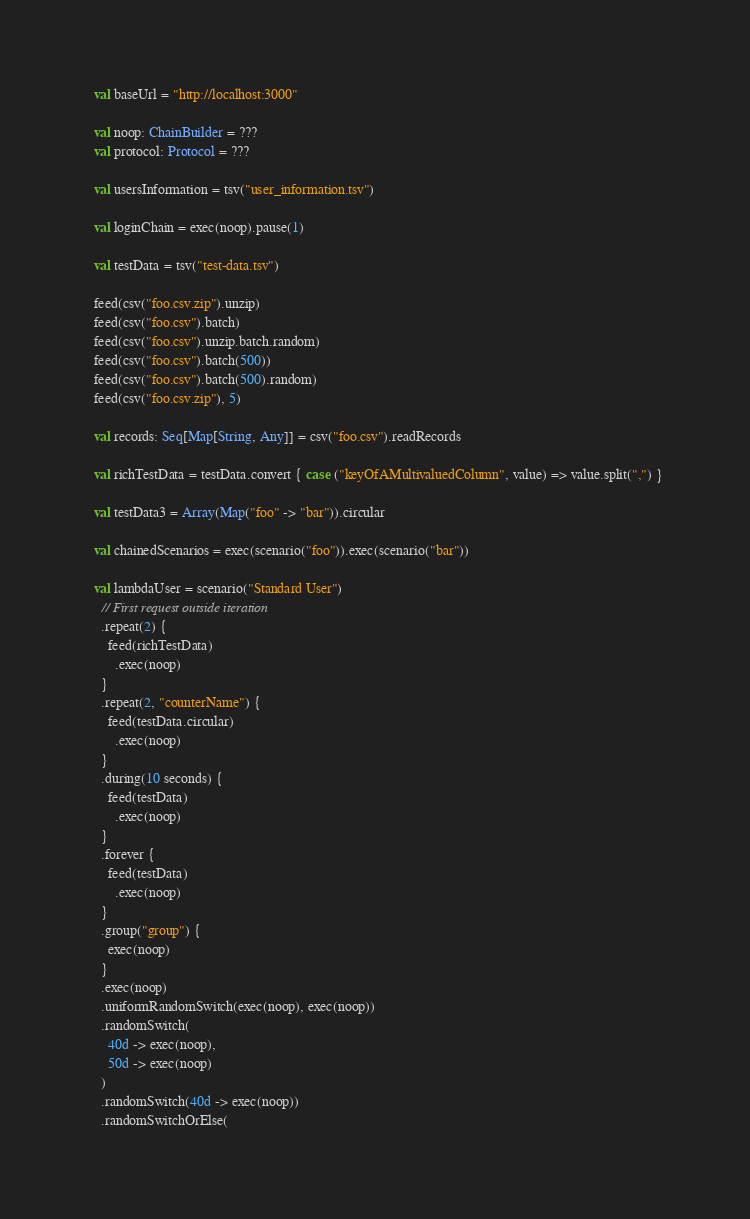<code> <loc_0><loc_0><loc_500><loc_500><_Scala_>
  val baseUrl = "http://localhost:3000"

  val noop: ChainBuilder = ???
  val protocol: Protocol = ???

  val usersInformation = tsv("user_information.tsv")

  val loginChain = exec(noop).pause(1)

  val testData = tsv("test-data.tsv")

  feed(csv("foo.csv.zip").unzip)
  feed(csv("foo.csv").batch)
  feed(csv("foo.csv").unzip.batch.random)
  feed(csv("foo.csv").batch(500))
  feed(csv("foo.csv").batch(500).random)
  feed(csv("foo.csv.zip"), 5)

  val records: Seq[Map[String, Any]] = csv("foo.csv").readRecords

  val richTestData = testData.convert { case ("keyOfAMultivaluedColumn", value) => value.split(",") }

  val testData3 = Array(Map("foo" -> "bar")).circular

  val chainedScenarios = exec(scenario("foo")).exec(scenario("bar"))

  val lambdaUser = scenario("Standard User")
    // First request outside iteration
    .repeat(2) {
      feed(richTestData)
        .exec(noop)
    }
    .repeat(2, "counterName") {
      feed(testData.circular)
        .exec(noop)
    }
    .during(10 seconds) {
      feed(testData)
        .exec(noop)
    }
    .forever {
      feed(testData)
        .exec(noop)
    }
    .group("group") {
      exec(noop)
    }
    .exec(noop)
    .uniformRandomSwitch(exec(noop), exec(noop))
    .randomSwitch(
      40d -> exec(noop),
      50d -> exec(noop)
    )
    .randomSwitch(40d -> exec(noop))
    .randomSwitchOrElse(</code> 